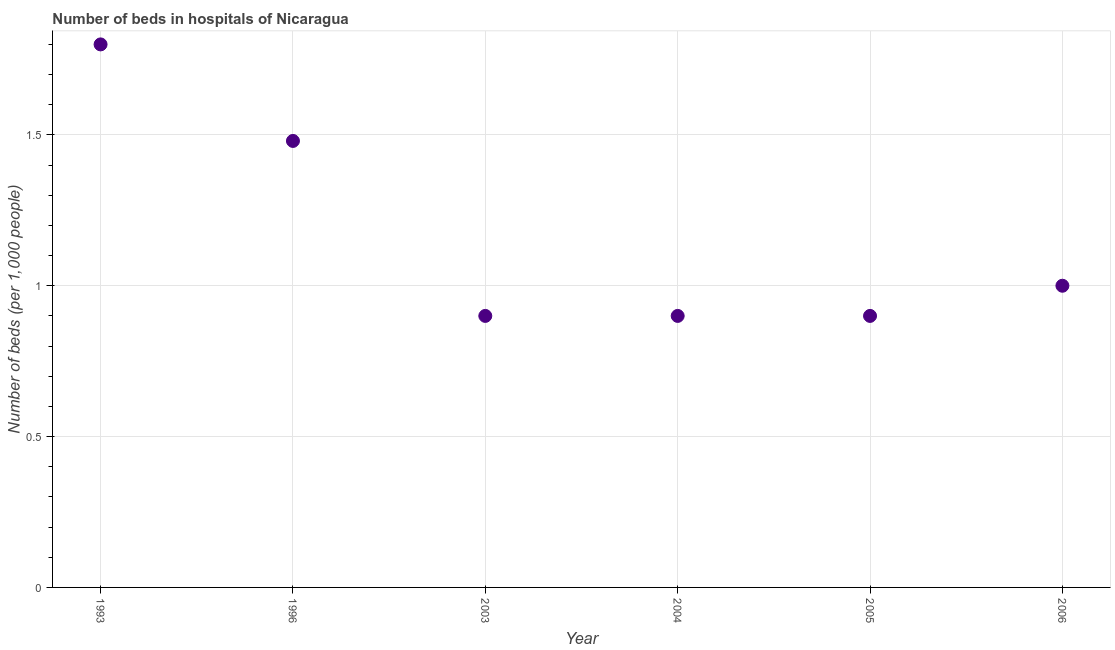What is the number of hospital beds in 2003?
Provide a succinct answer. 0.9. Across all years, what is the maximum number of hospital beds?
Provide a succinct answer. 1.8. Across all years, what is the minimum number of hospital beds?
Offer a very short reply. 0.9. In which year was the number of hospital beds maximum?
Ensure brevity in your answer.  1993. What is the sum of the number of hospital beds?
Your answer should be very brief. 6.98. What is the difference between the number of hospital beds in 1996 and 2006?
Give a very brief answer. 0.48. What is the average number of hospital beds per year?
Give a very brief answer. 1.16. What is the ratio of the number of hospital beds in 1996 to that in 2006?
Make the answer very short. 1.48. What is the difference between the highest and the second highest number of hospital beds?
Your answer should be compact. 0.32. Is the sum of the number of hospital beds in 1993 and 1996 greater than the maximum number of hospital beds across all years?
Ensure brevity in your answer.  Yes. What is the difference between the highest and the lowest number of hospital beds?
Your answer should be very brief. 0.9. Does the number of hospital beds monotonically increase over the years?
Your response must be concise. No. How many dotlines are there?
Keep it short and to the point. 1. What is the difference between two consecutive major ticks on the Y-axis?
Ensure brevity in your answer.  0.5. What is the title of the graph?
Ensure brevity in your answer.  Number of beds in hospitals of Nicaragua. What is the label or title of the X-axis?
Your response must be concise. Year. What is the label or title of the Y-axis?
Keep it short and to the point. Number of beds (per 1,0 people). What is the Number of beds (per 1,000 people) in 1993?
Ensure brevity in your answer.  1.8. What is the Number of beds (per 1,000 people) in 1996?
Your response must be concise. 1.48. What is the Number of beds (per 1,000 people) in 2003?
Ensure brevity in your answer.  0.9. What is the Number of beds (per 1,000 people) in 2004?
Keep it short and to the point. 0.9. What is the Number of beds (per 1,000 people) in 2005?
Provide a succinct answer. 0.9. What is the difference between the Number of beds (per 1,000 people) in 1993 and 1996?
Offer a very short reply. 0.32. What is the difference between the Number of beds (per 1,000 people) in 1993 and 2003?
Keep it short and to the point. 0.9. What is the difference between the Number of beds (per 1,000 people) in 1996 and 2003?
Make the answer very short. 0.58. What is the difference between the Number of beds (per 1,000 people) in 1996 and 2004?
Give a very brief answer. 0.58. What is the difference between the Number of beds (per 1,000 people) in 1996 and 2005?
Make the answer very short. 0.58. What is the difference between the Number of beds (per 1,000 people) in 1996 and 2006?
Make the answer very short. 0.48. What is the difference between the Number of beds (per 1,000 people) in 2003 and 2005?
Make the answer very short. -0. What is the difference between the Number of beds (per 1,000 people) in 2003 and 2006?
Your response must be concise. -0.1. What is the difference between the Number of beds (per 1,000 people) in 2004 and 2005?
Your response must be concise. 0. What is the difference between the Number of beds (per 1,000 people) in 2004 and 2006?
Provide a short and direct response. -0.1. What is the ratio of the Number of beds (per 1,000 people) in 1993 to that in 1996?
Keep it short and to the point. 1.22. What is the ratio of the Number of beds (per 1,000 people) in 1993 to that in 2005?
Provide a succinct answer. 2. What is the ratio of the Number of beds (per 1,000 people) in 1996 to that in 2003?
Make the answer very short. 1.64. What is the ratio of the Number of beds (per 1,000 people) in 1996 to that in 2004?
Your answer should be very brief. 1.64. What is the ratio of the Number of beds (per 1,000 people) in 1996 to that in 2005?
Give a very brief answer. 1.64. What is the ratio of the Number of beds (per 1,000 people) in 1996 to that in 2006?
Your answer should be compact. 1.48. What is the ratio of the Number of beds (per 1,000 people) in 2004 to that in 2005?
Make the answer very short. 1. What is the ratio of the Number of beds (per 1,000 people) in 2004 to that in 2006?
Keep it short and to the point. 0.9. 